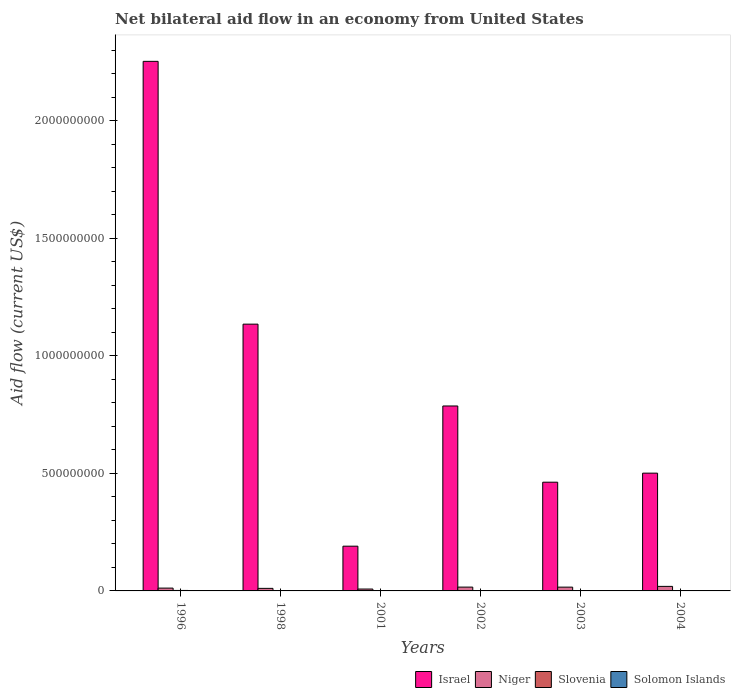How many different coloured bars are there?
Make the answer very short. 4. How many groups of bars are there?
Offer a very short reply. 6. In how many cases, is the number of bars for a given year not equal to the number of legend labels?
Offer a very short reply. 0. What is the net bilateral aid flow in Solomon Islands in 2001?
Keep it short and to the point. 7.00e+04. Across all years, what is the maximum net bilateral aid flow in Israel?
Keep it short and to the point. 2.25e+09. Across all years, what is the minimum net bilateral aid flow in Israel?
Keep it short and to the point. 1.90e+08. In which year was the net bilateral aid flow in Niger minimum?
Provide a succinct answer. 2001. What is the total net bilateral aid flow in Solomon Islands in the graph?
Provide a succinct answer. 1.99e+06. What is the difference between the net bilateral aid flow in Slovenia in 1996 and that in 2002?
Offer a terse response. 1.70e+06. What is the difference between the net bilateral aid flow in Israel in 2002 and the net bilateral aid flow in Solomon Islands in 1996?
Keep it short and to the point. 7.86e+08. What is the average net bilateral aid flow in Israel per year?
Give a very brief answer. 8.88e+08. In the year 2004, what is the difference between the net bilateral aid flow in Solomon Islands and net bilateral aid flow in Slovenia?
Your answer should be compact. -8.30e+05. What is the ratio of the net bilateral aid flow in Israel in 1998 to that in 2003?
Give a very brief answer. 2.45. Is the difference between the net bilateral aid flow in Solomon Islands in 1998 and 2002 greater than the difference between the net bilateral aid flow in Slovenia in 1998 and 2002?
Keep it short and to the point. Yes. What is the difference between the highest and the second highest net bilateral aid flow in Niger?
Provide a succinct answer. 3.05e+06. What is the difference between the highest and the lowest net bilateral aid flow in Slovenia?
Your answer should be very brief. 1.99e+06. Is the sum of the net bilateral aid flow in Solomon Islands in 1996 and 1998 greater than the maximum net bilateral aid flow in Israel across all years?
Your answer should be very brief. No. Is it the case that in every year, the sum of the net bilateral aid flow in Slovenia and net bilateral aid flow in Solomon Islands is greater than the sum of net bilateral aid flow in Israel and net bilateral aid flow in Niger?
Your answer should be compact. Yes. What does the 4th bar from the left in 2004 represents?
Your response must be concise. Solomon Islands. What does the 3rd bar from the right in 1996 represents?
Provide a short and direct response. Niger. Is it the case that in every year, the sum of the net bilateral aid flow in Solomon Islands and net bilateral aid flow in Israel is greater than the net bilateral aid flow in Niger?
Keep it short and to the point. Yes. How many bars are there?
Your answer should be compact. 24. What is the difference between two consecutive major ticks on the Y-axis?
Ensure brevity in your answer.  5.00e+08. Does the graph contain any zero values?
Provide a short and direct response. No. Where does the legend appear in the graph?
Ensure brevity in your answer.  Bottom right. How are the legend labels stacked?
Make the answer very short. Horizontal. What is the title of the graph?
Your answer should be compact. Net bilateral aid flow in an economy from United States. Does "Latvia" appear as one of the legend labels in the graph?
Ensure brevity in your answer.  No. What is the label or title of the X-axis?
Provide a short and direct response. Years. What is the label or title of the Y-axis?
Provide a short and direct response. Aid flow (current US$). What is the Aid flow (current US$) of Israel in 1996?
Provide a short and direct response. 2.25e+09. What is the Aid flow (current US$) in Niger in 1996?
Keep it short and to the point. 1.20e+07. What is the Aid flow (current US$) in Slovenia in 1996?
Your answer should be compact. 2.00e+06. What is the Aid flow (current US$) of Solomon Islands in 1996?
Your response must be concise. 1.00e+06. What is the Aid flow (current US$) in Israel in 1998?
Your answer should be very brief. 1.13e+09. What is the Aid flow (current US$) of Niger in 1998?
Provide a short and direct response. 1.08e+07. What is the Aid flow (current US$) in Slovenia in 1998?
Ensure brevity in your answer.  10000. What is the Aid flow (current US$) in Solomon Islands in 1998?
Your answer should be very brief. 7.60e+05. What is the Aid flow (current US$) in Israel in 2001?
Give a very brief answer. 1.90e+08. What is the Aid flow (current US$) of Niger in 2001?
Provide a short and direct response. 8.02e+06. What is the Aid flow (current US$) of Slovenia in 2001?
Your answer should be compact. 6.60e+05. What is the Aid flow (current US$) in Solomon Islands in 2001?
Ensure brevity in your answer.  7.00e+04. What is the Aid flow (current US$) of Israel in 2002?
Your response must be concise. 7.87e+08. What is the Aid flow (current US$) of Niger in 2002?
Your answer should be compact. 1.63e+07. What is the Aid flow (current US$) in Solomon Islands in 2002?
Provide a short and direct response. 6.00e+04. What is the Aid flow (current US$) in Israel in 2003?
Your response must be concise. 4.63e+08. What is the Aid flow (current US$) of Niger in 2003?
Keep it short and to the point. 1.61e+07. What is the Aid flow (current US$) in Slovenia in 2003?
Provide a short and direct response. 6.30e+05. What is the Aid flow (current US$) of Solomon Islands in 2003?
Give a very brief answer. 7.00e+04. What is the Aid flow (current US$) of Israel in 2004?
Offer a terse response. 5.01e+08. What is the Aid flow (current US$) in Niger in 2004?
Ensure brevity in your answer.  1.93e+07. What is the Aid flow (current US$) of Slovenia in 2004?
Provide a short and direct response. 8.60e+05. Across all years, what is the maximum Aid flow (current US$) in Israel?
Provide a short and direct response. 2.25e+09. Across all years, what is the maximum Aid flow (current US$) of Niger?
Offer a terse response. 1.93e+07. Across all years, what is the maximum Aid flow (current US$) in Slovenia?
Give a very brief answer. 2.00e+06. Across all years, what is the minimum Aid flow (current US$) in Israel?
Provide a short and direct response. 1.90e+08. Across all years, what is the minimum Aid flow (current US$) of Niger?
Give a very brief answer. 8.02e+06. Across all years, what is the minimum Aid flow (current US$) in Solomon Islands?
Provide a succinct answer. 3.00e+04. What is the total Aid flow (current US$) in Israel in the graph?
Your response must be concise. 5.33e+09. What is the total Aid flow (current US$) in Niger in the graph?
Provide a short and direct response. 8.26e+07. What is the total Aid flow (current US$) of Slovenia in the graph?
Keep it short and to the point. 4.46e+06. What is the total Aid flow (current US$) in Solomon Islands in the graph?
Provide a succinct answer. 1.99e+06. What is the difference between the Aid flow (current US$) of Israel in 1996 and that in 1998?
Your answer should be very brief. 1.12e+09. What is the difference between the Aid flow (current US$) of Niger in 1996 and that in 1998?
Ensure brevity in your answer.  1.16e+06. What is the difference between the Aid flow (current US$) of Slovenia in 1996 and that in 1998?
Provide a short and direct response. 1.99e+06. What is the difference between the Aid flow (current US$) in Solomon Islands in 1996 and that in 1998?
Provide a succinct answer. 2.40e+05. What is the difference between the Aid flow (current US$) in Israel in 1996 and that in 2001?
Give a very brief answer. 2.06e+09. What is the difference between the Aid flow (current US$) in Niger in 1996 and that in 2001?
Your answer should be compact. 3.98e+06. What is the difference between the Aid flow (current US$) of Slovenia in 1996 and that in 2001?
Your answer should be very brief. 1.34e+06. What is the difference between the Aid flow (current US$) of Solomon Islands in 1996 and that in 2001?
Offer a very short reply. 9.30e+05. What is the difference between the Aid flow (current US$) in Israel in 1996 and that in 2002?
Your answer should be compact. 1.47e+09. What is the difference between the Aid flow (current US$) of Niger in 1996 and that in 2002?
Your response must be concise. -4.27e+06. What is the difference between the Aid flow (current US$) of Slovenia in 1996 and that in 2002?
Make the answer very short. 1.70e+06. What is the difference between the Aid flow (current US$) of Solomon Islands in 1996 and that in 2002?
Ensure brevity in your answer.  9.40e+05. What is the difference between the Aid flow (current US$) in Israel in 1996 and that in 2003?
Keep it short and to the point. 1.79e+09. What is the difference between the Aid flow (current US$) of Niger in 1996 and that in 2003?
Keep it short and to the point. -4.13e+06. What is the difference between the Aid flow (current US$) in Slovenia in 1996 and that in 2003?
Offer a terse response. 1.37e+06. What is the difference between the Aid flow (current US$) in Solomon Islands in 1996 and that in 2003?
Keep it short and to the point. 9.30e+05. What is the difference between the Aid flow (current US$) of Israel in 1996 and that in 2004?
Ensure brevity in your answer.  1.75e+09. What is the difference between the Aid flow (current US$) of Niger in 1996 and that in 2004?
Provide a succinct answer. -7.32e+06. What is the difference between the Aid flow (current US$) in Slovenia in 1996 and that in 2004?
Provide a succinct answer. 1.14e+06. What is the difference between the Aid flow (current US$) in Solomon Islands in 1996 and that in 2004?
Give a very brief answer. 9.70e+05. What is the difference between the Aid flow (current US$) of Israel in 1998 and that in 2001?
Your response must be concise. 9.45e+08. What is the difference between the Aid flow (current US$) of Niger in 1998 and that in 2001?
Your response must be concise. 2.82e+06. What is the difference between the Aid flow (current US$) of Slovenia in 1998 and that in 2001?
Make the answer very short. -6.50e+05. What is the difference between the Aid flow (current US$) of Solomon Islands in 1998 and that in 2001?
Make the answer very short. 6.90e+05. What is the difference between the Aid flow (current US$) of Israel in 1998 and that in 2002?
Make the answer very short. 3.48e+08. What is the difference between the Aid flow (current US$) of Niger in 1998 and that in 2002?
Make the answer very short. -5.43e+06. What is the difference between the Aid flow (current US$) of Israel in 1998 and that in 2003?
Provide a short and direct response. 6.72e+08. What is the difference between the Aid flow (current US$) in Niger in 1998 and that in 2003?
Your answer should be compact. -5.29e+06. What is the difference between the Aid flow (current US$) in Slovenia in 1998 and that in 2003?
Ensure brevity in your answer.  -6.20e+05. What is the difference between the Aid flow (current US$) in Solomon Islands in 1998 and that in 2003?
Make the answer very short. 6.90e+05. What is the difference between the Aid flow (current US$) of Israel in 1998 and that in 2004?
Provide a short and direct response. 6.34e+08. What is the difference between the Aid flow (current US$) in Niger in 1998 and that in 2004?
Make the answer very short. -8.48e+06. What is the difference between the Aid flow (current US$) of Slovenia in 1998 and that in 2004?
Provide a short and direct response. -8.50e+05. What is the difference between the Aid flow (current US$) of Solomon Islands in 1998 and that in 2004?
Offer a very short reply. 7.30e+05. What is the difference between the Aid flow (current US$) in Israel in 2001 and that in 2002?
Keep it short and to the point. -5.96e+08. What is the difference between the Aid flow (current US$) in Niger in 2001 and that in 2002?
Keep it short and to the point. -8.25e+06. What is the difference between the Aid flow (current US$) in Israel in 2001 and that in 2003?
Provide a succinct answer. -2.72e+08. What is the difference between the Aid flow (current US$) in Niger in 2001 and that in 2003?
Make the answer very short. -8.11e+06. What is the difference between the Aid flow (current US$) of Slovenia in 2001 and that in 2003?
Ensure brevity in your answer.  3.00e+04. What is the difference between the Aid flow (current US$) of Israel in 2001 and that in 2004?
Your response must be concise. -3.11e+08. What is the difference between the Aid flow (current US$) in Niger in 2001 and that in 2004?
Keep it short and to the point. -1.13e+07. What is the difference between the Aid flow (current US$) in Slovenia in 2001 and that in 2004?
Your response must be concise. -2.00e+05. What is the difference between the Aid flow (current US$) in Solomon Islands in 2001 and that in 2004?
Give a very brief answer. 4.00e+04. What is the difference between the Aid flow (current US$) in Israel in 2002 and that in 2003?
Your answer should be compact. 3.24e+08. What is the difference between the Aid flow (current US$) in Niger in 2002 and that in 2003?
Your answer should be very brief. 1.40e+05. What is the difference between the Aid flow (current US$) of Slovenia in 2002 and that in 2003?
Keep it short and to the point. -3.30e+05. What is the difference between the Aid flow (current US$) in Solomon Islands in 2002 and that in 2003?
Keep it short and to the point. -10000. What is the difference between the Aid flow (current US$) of Israel in 2002 and that in 2004?
Give a very brief answer. 2.86e+08. What is the difference between the Aid flow (current US$) in Niger in 2002 and that in 2004?
Offer a terse response. -3.05e+06. What is the difference between the Aid flow (current US$) of Slovenia in 2002 and that in 2004?
Keep it short and to the point. -5.60e+05. What is the difference between the Aid flow (current US$) in Israel in 2003 and that in 2004?
Give a very brief answer. -3.85e+07. What is the difference between the Aid flow (current US$) in Niger in 2003 and that in 2004?
Offer a very short reply. -3.19e+06. What is the difference between the Aid flow (current US$) of Solomon Islands in 2003 and that in 2004?
Give a very brief answer. 4.00e+04. What is the difference between the Aid flow (current US$) of Israel in 1996 and the Aid flow (current US$) of Niger in 1998?
Your answer should be compact. 2.24e+09. What is the difference between the Aid flow (current US$) in Israel in 1996 and the Aid flow (current US$) in Slovenia in 1998?
Your response must be concise. 2.25e+09. What is the difference between the Aid flow (current US$) in Israel in 1996 and the Aid flow (current US$) in Solomon Islands in 1998?
Your response must be concise. 2.25e+09. What is the difference between the Aid flow (current US$) of Niger in 1996 and the Aid flow (current US$) of Slovenia in 1998?
Offer a terse response. 1.20e+07. What is the difference between the Aid flow (current US$) in Niger in 1996 and the Aid flow (current US$) in Solomon Islands in 1998?
Offer a terse response. 1.12e+07. What is the difference between the Aid flow (current US$) of Slovenia in 1996 and the Aid flow (current US$) of Solomon Islands in 1998?
Offer a very short reply. 1.24e+06. What is the difference between the Aid flow (current US$) in Israel in 1996 and the Aid flow (current US$) in Niger in 2001?
Your answer should be very brief. 2.24e+09. What is the difference between the Aid flow (current US$) in Israel in 1996 and the Aid flow (current US$) in Slovenia in 2001?
Make the answer very short. 2.25e+09. What is the difference between the Aid flow (current US$) of Israel in 1996 and the Aid flow (current US$) of Solomon Islands in 2001?
Your response must be concise. 2.25e+09. What is the difference between the Aid flow (current US$) of Niger in 1996 and the Aid flow (current US$) of Slovenia in 2001?
Make the answer very short. 1.13e+07. What is the difference between the Aid flow (current US$) in Niger in 1996 and the Aid flow (current US$) in Solomon Islands in 2001?
Your answer should be compact. 1.19e+07. What is the difference between the Aid flow (current US$) in Slovenia in 1996 and the Aid flow (current US$) in Solomon Islands in 2001?
Provide a succinct answer. 1.93e+06. What is the difference between the Aid flow (current US$) in Israel in 1996 and the Aid flow (current US$) in Niger in 2002?
Ensure brevity in your answer.  2.24e+09. What is the difference between the Aid flow (current US$) of Israel in 1996 and the Aid flow (current US$) of Slovenia in 2002?
Offer a very short reply. 2.25e+09. What is the difference between the Aid flow (current US$) in Israel in 1996 and the Aid flow (current US$) in Solomon Islands in 2002?
Offer a very short reply. 2.25e+09. What is the difference between the Aid flow (current US$) of Niger in 1996 and the Aid flow (current US$) of Slovenia in 2002?
Offer a very short reply. 1.17e+07. What is the difference between the Aid flow (current US$) of Niger in 1996 and the Aid flow (current US$) of Solomon Islands in 2002?
Your answer should be very brief. 1.19e+07. What is the difference between the Aid flow (current US$) in Slovenia in 1996 and the Aid flow (current US$) in Solomon Islands in 2002?
Ensure brevity in your answer.  1.94e+06. What is the difference between the Aid flow (current US$) of Israel in 1996 and the Aid flow (current US$) of Niger in 2003?
Provide a succinct answer. 2.24e+09. What is the difference between the Aid flow (current US$) in Israel in 1996 and the Aid flow (current US$) in Slovenia in 2003?
Ensure brevity in your answer.  2.25e+09. What is the difference between the Aid flow (current US$) of Israel in 1996 and the Aid flow (current US$) of Solomon Islands in 2003?
Your answer should be very brief. 2.25e+09. What is the difference between the Aid flow (current US$) in Niger in 1996 and the Aid flow (current US$) in Slovenia in 2003?
Ensure brevity in your answer.  1.14e+07. What is the difference between the Aid flow (current US$) of Niger in 1996 and the Aid flow (current US$) of Solomon Islands in 2003?
Your answer should be compact. 1.19e+07. What is the difference between the Aid flow (current US$) in Slovenia in 1996 and the Aid flow (current US$) in Solomon Islands in 2003?
Ensure brevity in your answer.  1.93e+06. What is the difference between the Aid flow (current US$) of Israel in 1996 and the Aid flow (current US$) of Niger in 2004?
Your answer should be compact. 2.23e+09. What is the difference between the Aid flow (current US$) of Israel in 1996 and the Aid flow (current US$) of Slovenia in 2004?
Offer a terse response. 2.25e+09. What is the difference between the Aid flow (current US$) in Israel in 1996 and the Aid flow (current US$) in Solomon Islands in 2004?
Make the answer very short. 2.25e+09. What is the difference between the Aid flow (current US$) in Niger in 1996 and the Aid flow (current US$) in Slovenia in 2004?
Make the answer very short. 1.11e+07. What is the difference between the Aid flow (current US$) in Niger in 1996 and the Aid flow (current US$) in Solomon Islands in 2004?
Offer a very short reply. 1.20e+07. What is the difference between the Aid flow (current US$) of Slovenia in 1996 and the Aid flow (current US$) of Solomon Islands in 2004?
Give a very brief answer. 1.97e+06. What is the difference between the Aid flow (current US$) in Israel in 1998 and the Aid flow (current US$) in Niger in 2001?
Provide a succinct answer. 1.13e+09. What is the difference between the Aid flow (current US$) of Israel in 1998 and the Aid flow (current US$) of Slovenia in 2001?
Keep it short and to the point. 1.13e+09. What is the difference between the Aid flow (current US$) of Israel in 1998 and the Aid flow (current US$) of Solomon Islands in 2001?
Provide a succinct answer. 1.13e+09. What is the difference between the Aid flow (current US$) in Niger in 1998 and the Aid flow (current US$) in Slovenia in 2001?
Ensure brevity in your answer.  1.02e+07. What is the difference between the Aid flow (current US$) in Niger in 1998 and the Aid flow (current US$) in Solomon Islands in 2001?
Make the answer very short. 1.08e+07. What is the difference between the Aid flow (current US$) of Israel in 1998 and the Aid flow (current US$) of Niger in 2002?
Provide a short and direct response. 1.12e+09. What is the difference between the Aid flow (current US$) in Israel in 1998 and the Aid flow (current US$) in Slovenia in 2002?
Provide a short and direct response. 1.13e+09. What is the difference between the Aid flow (current US$) of Israel in 1998 and the Aid flow (current US$) of Solomon Islands in 2002?
Give a very brief answer. 1.13e+09. What is the difference between the Aid flow (current US$) in Niger in 1998 and the Aid flow (current US$) in Slovenia in 2002?
Provide a succinct answer. 1.05e+07. What is the difference between the Aid flow (current US$) in Niger in 1998 and the Aid flow (current US$) in Solomon Islands in 2002?
Your response must be concise. 1.08e+07. What is the difference between the Aid flow (current US$) in Slovenia in 1998 and the Aid flow (current US$) in Solomon Islands in 2002?
Give a very brief answer. -5.00e+04. What is the difference between the Aid flow (current US$) of Israel in 1998 and the Aid flow (current US$) of Niger in 2003?
Provide a short and direct response. 1.12e+09. What is the difference between the Aid flow (current US$) of Israel in 1998 and the Aid flow (current US$) of Slovenia in 2003?
Provide a succinct answer. 1.13e+09. What is the difference between the Aid flow (current US$) of Israel in 1998 and the Aid flow (current US$) of Solomon Islands in 2003?
Keep it short and to the point. 1.13e+09. What is the difference between the Aid flow (current US$) in Niger in 1998 and the Aid flow (current US$) in Slovenia in 2003?
Provide a short and direct response. 1.02e+07. What is the difference between the Aid flow (current US$) in Niger in 1998 and the Aid flow (current US$) in Solomon Islands in 2003?
Your response must be concise. 1.08e+07. What is the difference between the Aid flow (current US$) in Israel in 1998 and the Aid flow (current US$) in Niger in 2004?
Offer a terse response. 1.12e+09. What is the difference between the Aid flow (current US$) in Israel in 1998 and the Aid flow (current US$) in Slovenia in 2004?
Give a very brief answer. 1.13e+09. What is the difference between the Aid flow (current US$) of Israel in 1998 and the Aid flow (current US$) of Solomon Islands in 2004?
Provide a short and direct response. 1.13e+09. What is the difference between the Aid flow (current US$) in Niger in 1998 and the Aid flow (current US$) in Slovenia in 2004?
Your answer should be compact. 9.98e+06. What is the difference between the Aid flow (current US$) of Niger in 1998 and the Aid flow (current US$) of Solomon Islands in 2004?
Give a very brief answer. 1.08e+07. What is the difference between the Aid flow (current US$) in Israel in 2001 and the Aid flow (current US$) in Niger in 2002?
Offer a terse response. 1.74e+08. What is the difference between the Aid flow (current US$) of Israel in 2001 and the Aid flow (current US$) of Slovenia in 2002?
Your response must be concise. 1.90e+08. What is the difference between the Aid flow (current US$) of Israel in 2001 and the Aid flow (current US$) of Solomon Islands in 2002?
Make the answer very short. 1.90e+08. What is the difference between the Aid flow (current US$) in Niger in 2001 and the Aid flow (current US$) in Slovenia in 2002?
Ensure brevity in your answer.  7.72e+06. What is the difference between the Aid flow (current US$) in Niger in 2001 and the Aid flow (current US$) in Solomon Islands in 2002?
Give a very brief answer. 7.96e+06. What is the difference between the Aid flow (current US$) of Israel in 2001 and the Aid flow (current US$) of Niger in 2003?
Provide a short and direct response. 1.74e+08. What is the difference between the Aid flow (current US$) of Israel in 2001 and the Aid flow (current US$) of Slovenia in 2003?
Give a very brief answer. 1.90e+08. What is the difference between the Aid flow (current US$) in Israel in 2001 and the Aid flow (current US$) in Solomon Islands in 2003?
Keep it short and to the point. 1.90e+08. What is the difference between the Aid flow (current US$) of Niger in 2001 and the Aid flow (current US$) of Slovenia in 2003?
Provide a short and direct response. 7.39e+06. What is the difference between the Aid flow (current US$) of Niger in 2001 and the Aid flow (current US$) of Solomon Islands in 2003?
Ensure brevity in your answer.  7.95e+06. What is the difference between the Aid flow (current US$) in Slovenia in 2001 and the Aid flow (current US$) in Solomon Islands in 2003?
Give a very brief answer. 5.90e+05. What is the difference between the Aid flow (current US$) in Israel in 2001 and the Aid flow (current US$) in Niger in 2004?
Ensure brevity in your answer.  1.71e+08. What is the difference between the Aid flow (current US$) in Israel in 2001 and the Aid flow (current US$) in Slovenia in 2004?
Give a very brief answer. 1.89e+08. What is the difference between the Aid flow (current US$) in Israel in 2001 and the Aid flow (current US$) in Solomon Islands in 2004?
Ensure brevity in your answer.  1.90e+08. What is the difference between the Aid flow (current US$) of Niger in 2001 and the Aid flow (current US$) of Slovenia in 2004?
Your response must be concise. 7.16e+06. What is the difference between the Aid flow (current US$) of Niger in 2001 and the Aid flow (current US$) of Solomon Islands in 2004?
Keep it short and to the point. 7.99e+06. What is the difference between the Aid flow (current US$) in Slovenia in 2001 and the Aid flow (current US$) in Solomon Islands in 2004?
Your answer should be very brief. 6.30e+05. What is the difference between the Aid flow (current US$) in Israel in 2002 and the Aid flow (current US$) in Niger in 2003?
Your answer should be compact. 7.71e+08. What is the difference between the Aid flow (current US$) of Israel in 2002 and the Aid flow (current US$) of Slovenia in 2003?
Keep it short and to the point. 7.86e+08. What is the difference between the Aid flow (current US$) of Israel in 2002 and the Aid flow (current US$) of Solomon Islands in 2003?
Ensure brevity in your answer.  7.87e+08. What is the difference between the Aid flow (current US$) of Niger in 2002 and the Aid flow (current US$) of Slovenia in 2003?
Provide a short and direct response. 1.56e+07. What is the difference between the Aid flow (current US$) in Niger in 2002 and the Aid flow (current US$) in Solomon Islands in 2003?
Keep it short and to the point. 1.62e+07. What is the difference between the Aid flow (current US$) in Slovenia in 2002 and the Aid flow (current US$) in Solomon Islands in 2003?
Your response must be concise. 2.30e+05. What is the difference between the Aid flow (current US$) in Israel in 2002 and the Aid flow (current US$) in Niger in 2004?
Ensure brevity in your answer.  7.67e+08. What is the difference between the Aid flow (current US$) of Israel in 2002 and the Aid flow (current US$) of Slovenia in 2004?
Provide a short and direct response. 7.86e+08. What is the difference between the Aid flow (current US$) in Israel in 2002 and the Aid flow (current US$) in Solomon Islands in 2004?
Make the answer very short. 7.87e+08. What is the difference between the Aid flow (current US$) in Niger in 2002 and the Aid flow (current US$) in Slovenia in 2004?
Offer a terse response. 1.54e+07. What is the difference between the Aid flow (current US$) of Niger in 2002 and the Aid flow (current US$) of Solomon Islands in 2004?
Your answer should be very brief. 1.62e+07. What is the difference between the Aid flow (current US$) in Israel in 2003 and the Aid flow (current US$) in Niger in 2004?
Provide a short and direct response. 4.43e+08. What is the difference between the Aid flow (current US$) in Israel in 2003 and the Aid flow (current US$) in Slovenia in 2004?
Offer a very short reply. 4.62e+08. What is the difference between the Aid flow (current US$) of Israel in 2003 and the Aid flow (current US$) of Solomon Islands in 2004?
Your response must be concise. 4.63e+08. What is the difference between the Aid flow (current US$) in Niger in 2003 and the Aid flow (current US$) in Slovenia in 2004?
Your answer should be very brief. 1.53e+07. What is the difference between the Aid flow (current US$) of Niger in 2003 and the Aid flow (current US$) of Solomon Islands in 2004?
Provide a short and direct response. 1.61e+07. What is the difference between the Aid flow (current US$) of Slovenia in 2003 and the Aid flow (current US$) of Solomon Islands in 2004?
Your response must be concise. 6.00e+05. What is the average Aid flow (current US$) in Israel per year?
Provide a succinct answer. 8.88e+08. What is the average Aid flow (current US$) of Niger per year?
Give a very brief answer. 1.38e+07. What is the average Aid flow (current US$) of Slovenia per year?
Keep it short and to the point. 7.43e+05. What is the average Aid flow (current US$) in Solomon Islands per year?
Offer a very short reply. 3.32e+05. In the year 1996, what is the difference between the Aid flow (current US$) of Israel and Aid flow (current US$) of Niger?
Provide a succinct answer. 2.24e+09. In the year 1996, what is the difference between the Aid flow (current US$) in Israel and Aid flow (current US$) in Slovenia?
Your response must be concise. 2.25e+09. In the year 1996, what is the difference between the Aid flow (current US$) in Israel and Aid flow (current US$) in Solomon Islands?
Ensure brevity in your answer.  2.25e+09. In the year 1996, what is the difference between the Aid flow (current US$) of Niger and Aid flow (current US$) of Slovenia?
Provide a succinct answer. 1.00e+07. In the year 1996, what is the difference between the Aid flow (current US$) of Niger and Aid flow (current US$) of Solomon Islands?
Offer a very short reply. 1.10e+07. In the year 1996, what is the difference between the Aid flow (current US$) in Slovenia and Aid flow (current US$) in Solomon Islands?
Give a very brief answer. 1.00e+06. In the year 1998, what is the difference between the Aid flow (current US$) of Israel and Aid flow (current US$) of Niger?
Your answer should be very brief. 1.12e+09. In the year 1998, what is the difference between the Aid flow (current US$) in Israel and Aid flow (current US$) in Slovenia?
Offer a terse response. 1.13e+09. In the year 1998, what is the difference between the Aid flow (current US$) in Israel and Aid flow (current US$) in Solomon Islands?
Ensure brevity in your answer.  1.13e+09. In the year 1998, what is the difference between the Aid flow (current US$) in Niger and Aid flow (current US$) in Slovenia?
Your answer should be very brief. 1.08e+07. In the year 1998, what is the difference between the Aid flow (current US$) in Niger and Aid flow (current US$) in Solomon Islands?
Your response must be concise. 1.01e+07. In the year 1998, what is the difference between the Aid flow (current US$) in Slovenia and Aid flow (current US$) in Solomon Islands?
Provide a short and direct response. -7.50e+05. In the year 2001, what is the difference between the Aid flow (current US$) of Israel and Aid flow (current US$) of Niger?
Give a very brief answer. 1.82e+08. In the year 2001, what is the difference between the Aid flow (current US$) in Israel and Aid flow (current US$) in Slovenia?
Make the answer very short. 1.90e+08. In the year 2001, what is the difference between the Aid flow (current US$) in Israel and Aid flow (current US$) in Solomon Islands?
Ensure brevity in your answer.  1.90e+08. In the year 2001, what is the difference between the Aid flow (current US$) in Niger and Aid flow (current US$) in Slovenia?
Your response must be concise. 7.36e+06. In the year 2001, what is the difference between the Aid flow (current US$) of Niger and Aid flow (current US$) of Solomon Islands?
Give a very brief answer. 7.95e+06. In the year 2001, what is the difference between the Aid flow (current US$) of Slovenia and Aid flow (current US$) of Solomon Islands?
Keep it short and to the point. 5.90e+05. In the year 2002, what is the difference between the Aid flow (current US$) in Israel and Aid flow (current US$) in Niger?
Your answer should be compact. 7.71e+08. In the year 2002, what is the difference between the Aid flow (current US$) of Israel and Aid flow (current US$) of Slovenia?
Offer a very short reply. 7.87e+08. In the year 2002, what is the difference between the Aid flow (current US$) in Israel and Aid flow (current US$) in Solomon Islands?
Your response must be concise. 7.87e+08. In the year 2002, what is the difference between the Aid flow (current US$) of Niger and Aid flow (current US$) of Slovenia?
Offer a very short reply. 1.60e+07. In the year 2002, what is the difference between the Aid flow (current US$) of Niger and Aid flow (current US$) of Solomon Islands?
Give a very brief answer. 1.62e+07. In the year 2003, what is the difference between the Aid flow (current US$) of Israel and Aid flow (current US$) of Niger?
Your answer should be very brief. 4.46e+08. In the year 2003, what is the difference between the Aid flow (current US$) in Israel and Aid flow (current US$) in Slovenia?
Make the answer very short. 4.62e+08. In the year 2003, what is the difference between the Aid flow (current US$) in Israel and Aid flow (current US$) in Solomon Islands?
Offer a very short reply. 4.62e+08. In the year 2003, what is the difference between the Aid flow (current US$) of Niger and Aid flow (current US$) of Slovenia?
Offer a very short reply. 1.55e+07. In the year 2003, what is the difference between the Aid flow (current US$) of Niger and Aid flow (current US$) of Solomon Islands?
Keep it short and to the point. 1.61e+07. In the year 2003, what is the difference between the Aid flow (current US$) of Slovenia and Aid flow (current US$) of Solomon Islands?
Keep it short and to the point. 5.60e+05. In the year 2004, what is the difference between the Aid flow (current US$) of Israel and Aid flow (current US$) of Niger?
Make the answer very short. 4.82e+08. In the year 2004, what is the difference between the Aid flow (current US$) of Israel and Aid flow (current US$) of Slovenia?
Provide a succinct answer. 5.00e+08. In the year 2004, what is the difference between the Aid flow (current US$) of Israel and Aid flow (current US$) of Solomon Islands?
Keep it short and to the point. 5.01e+08. In the year 2004, what is the difference between the Aid flow (current US$) in Niger and Aid flow (current US$) in Slovenia?
Keep it short and to the point. 1.85e+07. In the year 2004, what is the difference between the Aid flow (current US$) in Niger and Aid flow (current US$) in Solomon Islands?
Offer a terse response. 1.93e+07. In the year 2004, what is the difference between the Aid flow (current US$) of Slovenia and Aid flow (current US$) of Solomon Islands?
Ensure brevity in your answer.  8.30e+05. What is the ratio of the Aid flow (current US$) of Israel in 1996 to that in 1998?
Your answer should be compact. 1.99. What is the ratio of the Aid flow (current US$) in Niger in 1996 to that in 1998?
Offer a very short reply. 1.11. What is the ratio of the Aid flow (current US$) in Slovenia in 1996 to that in 1998?
Provide a succinct answer. 200. What is the ratio of the Aid flow (current US$) in Solomon Islands in 1996 to that in 1998?
Provide a succinct answer. 1.32. What is the ratio of the Aid flow (current US$) of Israel in 1996 to that in 2001?
Provide a succinct answer. 11.84. What is the ratio of the Aid flow (current US$) in Niger in 1996 to that in 2001?
Make the answer very short. 1.5. What is the ratio of the Aid flow (current US$) of Slovenia in 1996 to that in 2001?
Your answer should be compact. 3.03. What is the ratio of the Aid flow (current US$) of Solomon Islands in 1996 to that in 2001?
Provide a short and direct response. 14.29. What is the ratio of the Aid flow (current US$) in Israel in 1996 to that in 2002?
Your response must be concise. 2.86. What is the ratio of the Aid flow (current US$) in Niger in 1996 to that in 2002?
Your response must be concise. 0.74. What is the ratio of the Aid flow (current US$) in Solomon Islands in 1996 to that in 2002?
Ensure brevity in your answer.  16.67. What is the ratio of the Aid flow (current US$) of Israel in 1996 to that in 2003?
Make the answer very short. 4.87. What is the ratio of the Aid flow (current US$) of Niger in 1996 to that in 2003?
Your answer should be compact. 0.74. What is the ratio of the Aid flow (current US$) of Slovenia in 1996 to that in 2003?
Offer a very short reply. 3.17. What is the ratio of the Aid flow (current US$) of Solomon Islands in 1996 to that in 2003?
Provide a short and direct response. 14.29. What is the ratio of the Aid flow (current US$) of Israel in 1996 to that in 2004?
Ensure brevity in your answer.  4.5. What is the ratio of the Aid flow (current US$) of Niger in 1996 to that in 2004?
Keep it short and to the point. 0.62. What is the ratio of the Aid flow (current US$) in Slovenia in 1996 to that in 2004?
Your answer should be compact. 2.33. What is the ratio of the Aid flow (current US$) of Solomon Islands in 1996 to that in 2004?
Your answer should be compact. 33.33. What is the ratio of the Aid flow (current US$) of Israel in 1998 to that in 2001?
Ensure brevity in your answer.  5.96. What is the ratio of the Aid flow (current US$) of Niger in 1998 to that in 2001?
Keep it short and to the point. 1.35. What is the ratio of the Aid flow (current US$) in Slovenia in 1998 to that in 2001?
Provide a short and direct response. 0.02. What is the ratio of the Aid flow (current US$) of Solomon Islands in 1998 to that in 2001?
Give a very brief answer. 10.86. What is the ratio of the Aid flow (current US$) in Israel in 1998 to that in 2002?
Give a very brief answer. 1.44. What is the ratio of the Aid flow (current US$) of Niger in 1998 to that in 2002?
Provide a succinct answer. 0.67. What is the ratio of the Aid flow (current US$) of Solomon Islands in 1998 to that in 2002?
Offer a terse response. 12.67. What is the ratio of the Aid flow (current US$) of Israel in 1998 to that in 2003?
Your answer should be very brief. 2.45. What is the ratio of the Aid flow (current US$) of Niger in 1998 to that in 2003?
Provide a succinct answer. 0.67. What is the ratio of the Aid flow (current US$) in Slovenia in 1998 to that in 2003?
Make the answer very short. 0.02. What is the ratio of the Aid flow (current US$) of Solomon Islands in 1998 to that in 2003?
Offer a very short reply. 10.86. What is the ratio of the Aid flow (current US$) in Israel in 1998 to that in 2004?
Your answer should be very brief. 2.27. What is the ratio of the Aid flow (current US$) of Niger in 1998 to that in 2004?
Provide a short and direct response. 0.56. What is the ratio of the Aid flow (current US$) in Slovenia in 1998 to that in 2004?
Make the answer very short. 0.01. What is the ratio of the Aid flow (current US$) of Solomon Islands in 1998 to that in 2004?
Offer a very short reply. 25.33. What is the ratio of the Aid flow (current US$) of Israel in 2001 to that in 2002?
Ensure brevity in your answer.  0.24. What is the ratio of the Aid flow (current US$) of Niger in 2001 to that in 2002?
Offer a very short reply. 0.49. What is the ratio of the Aid flow (current US$) of Solomon Islands in 2001 to that in 2002?
Keep it short and to the point. 1.17. What is the ratio of the Aid flow (current US$) in Israel in 2001 to that in 2003?
Provide a succinct answer. 0.41. What is the ratio of the Aid flow (current US$) of Niger in 2001 to that in 2003?
Your response must be concise. 0.5. What is the ratio of the Aid flow (current US$) of Slovenia in 2001 to that in 2003?
Offer a terse response. 1.05. What is the ratio of the Aid flow (current US$) in Israel in 2001 to that in 2004?
Provide a short and direct response. 0.38. What is the ratio of the Aid flow (current US$) of Niger in 2001 to that in 2004?
Your answer should be very brief. 0.42. What is the ratio of the Aid flow (current US$) in Slovenia in 2001 to that in 2004?
Your response must be concise. 0.77. What is the ratio of the Aid flow (current US$) of Solomon Islands in 2001 to that in 2004?
Provide a short and direct response. 2.33. What is the ratio of the Aid flow (current US$) in Israel in 2002 to that in 2003?
Make the answer very short. 1.7. What is the ratio of the Aid flow (current US$) of Niger in 2002 to that in 2003?
Offer a terse response. 1.01. What is the ratio of the Aid flow (current US$) in Slovenia in 2002 to that in 2003?
Give a very brief answer. 0.48. What is the ratio of the Aid flow (current US$) in Israel in 2002 to that in 2004?
Your response must be concise. 1.57. What is the ratio of the Aid flow (current US$) in Niger in 2002 to that in 2004?
Your answer should be very brief. 0.84. What is the ratio of the Aid flow (current US$) in Slovenia in 2002 to that in 2004?
Your response must be concise. 0.35. What is the ratio of the Aid flow (current US$) of Solomon Islands in 2002 to that in 2004?
Your answer should be compact. 2. What is the ratio of the Aid flow (current US$) in Niger in 2003 to that in 2004?
Offer a very short reply. 0.83. What is the ratio of the Aid flow (current US$) in Slovenia in 2003 to that in 2004?
Give a very brief answer. 0.73. What is the ratio of the Aid flow (current US$) of Solomon Islands in 2003 to that in 2004?
Ensure brevity in your answer.  2.33. What is the difference between the highest and the second highest Aid flow (current US$) in Israel?
Keep it short and to the point. 1.12e+09. What is the difference between the highest and the second highest Aid flow (current US$) in Niger?
Provide a short and direct response. 3.05e+06. What is the difference between the highest and the second highest Aid flow (current US$) in Slovenia?
Make the answer very short. 1.14e+06. What is the difference between the highest and the second highest Aid flow (current US$) of Solomon Islands?
Keep it short and to the point. 2.40e+05. What is the difference between the highest and the lowest Aid flow (current US$) in Israel?
Your answer should be very brief. 2.06e+09. What is the difference between the highest and the lowest Aid flow (current US$) in Niger?
Your answer should be very brief. 1.13e+07. What is the difference between the highest and the lowest Aid flow (current US$) of Slovenia?
Give a very brief answer. 1.99e+06. What is the difference between the highest and the lowest Aid flow (current US$) of Solomon Islands?
Keep it short and to the point. 9.70e+05. 